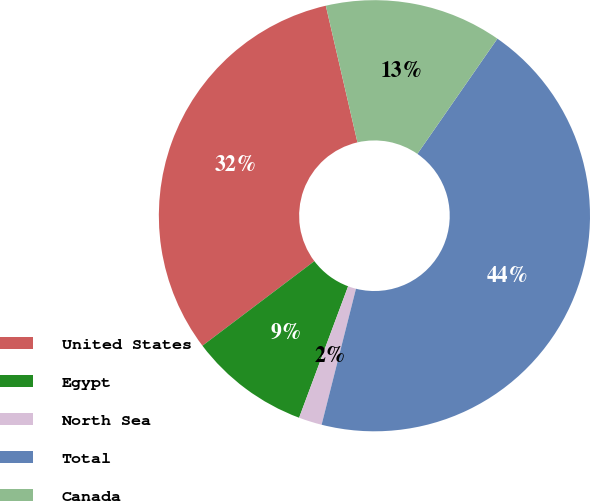Convert chart to OTSL. <chart><loc_0><loc_0><loc_500><loc_500><pie_chart><fcel>United States<fcel>Egypt<fcel>North Sea<fcel>Total<fcel>Canada<nl><fcel>31.68%<fcel>9.02%<fcel>1.74%<fcel>44.28%<fcel>13.28%<nl></chart> 